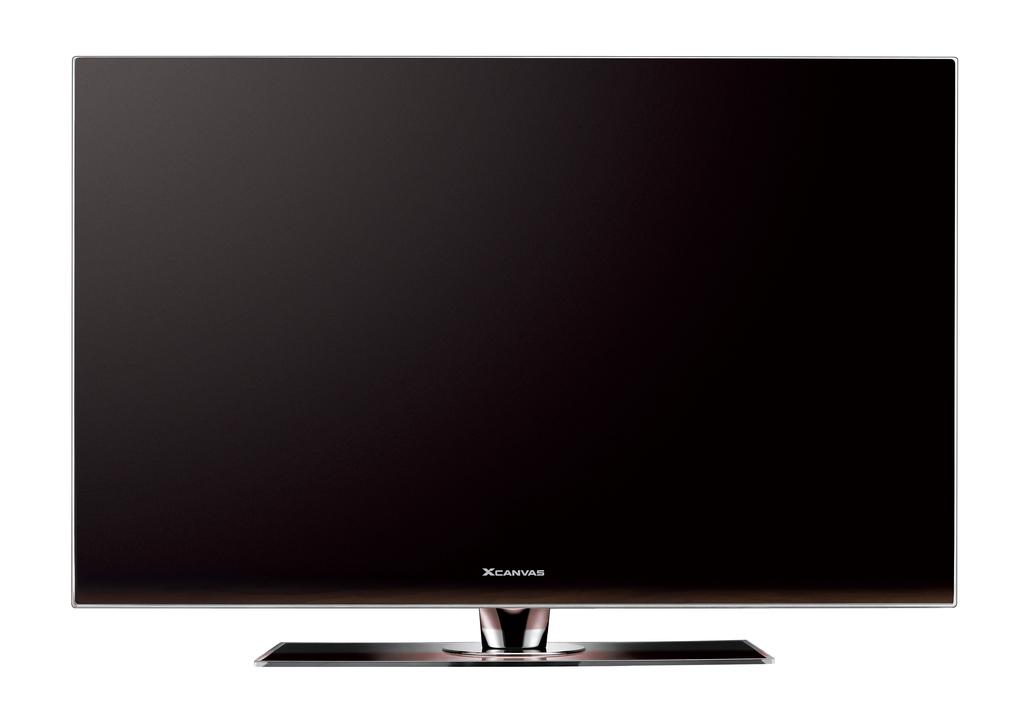What company's name is on the monitor?
Offer a very short reply. Xcanvas. 